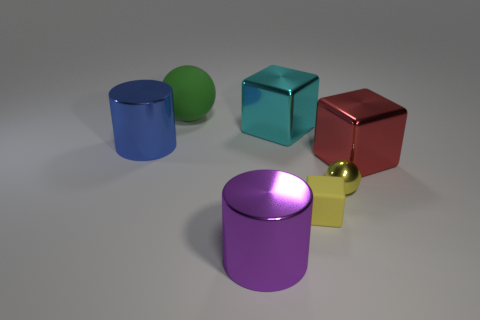Subtract all large cubes. How many cubes are left? 1 Subtract all purple cylinders. How many cylinders are left? 1 Add 1 tiny gray objects. How many objects exist? 8 Subtract 1 cylinders. How many cylinders are left? 1 Add 2 green matte objects. How many green matte objects are left? 3 Add 4 blue metallic cylinders. How many blue metallic cylinders exist? 5 Subtract 1 red cubes. How many objects are left? 6 Subtract all balls. How many objects are left? 5 Subtract all brown cylinders. Subtract all purple spheres. How many cylinders are left? 2 Subtract all red cubes. How many yellow spheres are left? 1 